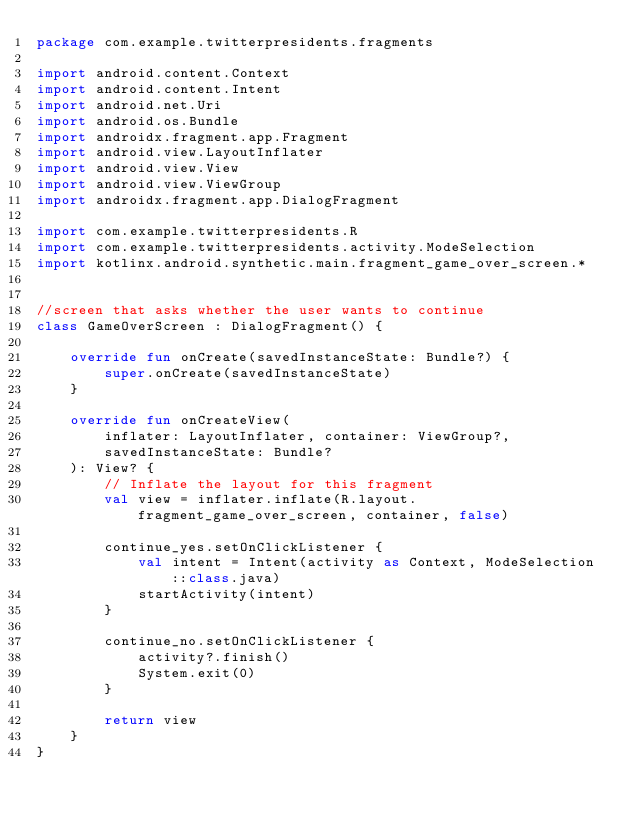<code> <loc_0><loc_0><loc_500><loc_500><_Kotlin_>package com.example.twitterpresidents.fragments

import android.content.Context
import android.content.Intent
import android.net.Uri
import android.os.Bundle
import androidx.fragment.app.Fragment
import android.view.LayoutInflater
import android.view.View
import android.view.ViewGroup
import androidx.fragment.app.DialogFragment

import com.example.twitterpresidents.R
import com.example.twitterpresidents.activity.ModeSelection
import kotlinx.android.synthetic.main.fragment_game_over_screen.*


//screen that asks whether the user wants to continue
class GameOverScreen : DialogFragment() {

    override fun onCreate(savedInstanceState: Bundle?) {
        super.onCreate(savedInstanceState)
    }

    override fun onCreateView(
        inflater: LayoutInflater, container: ViewGroup?,
        savedInstanceState: Bundle?
    ): View? {
        // Inflate the layout for this fragment
        val view = inflater.inflate(R.layout.fragment_game_over_screen, container, false)

        continue_yes.setOnClickListener {
            val intent = Intent(activity as Context, ModeSelection::class.java)
            startActivity(intent)
        }

        continue_no.setOnClickListener {
            activity?.finish()
            System.exit(0)
        }

        return view
    }
}
</code> 